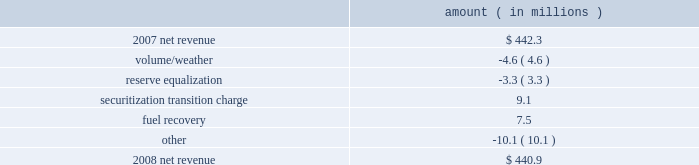Entergy texas , inc .
Management's financial discussion and analysis net revenue 2008 compared to 2007 net revenue consists of operating revenues net of : 1 ) fuel , fuel-related expenses , and gas purchased for resale , 2 ) purchased power expenses , and 3 ) other regulatory charges .
Following is an analysis of the change in net revenue comparing 2008 to 2007 .
Amount ( in millions ) .
The volume/weather variance is primarily due to decreased usage during the unbilled sales period .
See "critical accounting estimates" below and note 1 to the financial statements for further discussion of the accounting for unbilled revenues .
The reserve equalization variance is primarily due to lower reserve equalization revenue related to changes in the entergy system generation mix compared to the same period in 2007 .
The securitization transition charge variance is primarily due to the issuance of securitization bonds .
In june 2007 , entergy gulf states reconstruction funding i , a company wholly-owned and consolidated by entergy texas , issued securitization bonds and with the proceeds purchased from entergy texas the transition property , which is the right to recover from customers through a transition charge amounts sufficient to service the securitization bonds .
See note 5 to the financial statements for additional information regarding the securitization bonds .
The fuel recovery variance is primarily due to a reserve for potential rate refunds made in the first quarter 2007 as a result of a puct ruling related to the application of past puct rulings addressing transition to competition in texas .
The other variance is primarily caused by various operational effects of the jurisdictional separation on revenues and fuel and purchased power expenses .
Gross operating revenues , fuel and purchased power expenses , and other regulatory charges gross operating revenues increased $ 229.3 million primarily due to the following reasons : an increase of $ 157 million in fuel cost recovery revenues due to higher fuel rates and increased usage , partially offset by interim fuel refunds to customers for fuel cost recovery over-collections through november 2007 .
The refund was distributed over a two-month period beginning february 2008 .
The interim refund and the puct approval is discussed in note 2 to the financial statements ; an increase of $ 37.1 million in affiliated wholesale revenue primarily due to increases in the cost of energy ; an increase in transition charge amounts collected from customers to service the securitization bonds as discussed above .
See note 5 to the financial statements for additional information regarding the securitization bonds ; and implementation of an interim surcharge to collect $ 10.3 million in under-recovered incremental purchased capacity costs incurred through july 2007 .
The surcharge was collected over a two-month period beginning february 2008 .
The incremental capacity recovery rider and puct approval is discussed in note 2 to the financial statements. .
What percent of the net change in revenue between 2007 and 2008 was due to fuel recovery? 
Computations: (7.5 / (440.9 - 442.3))
Answer: -5.35714. 